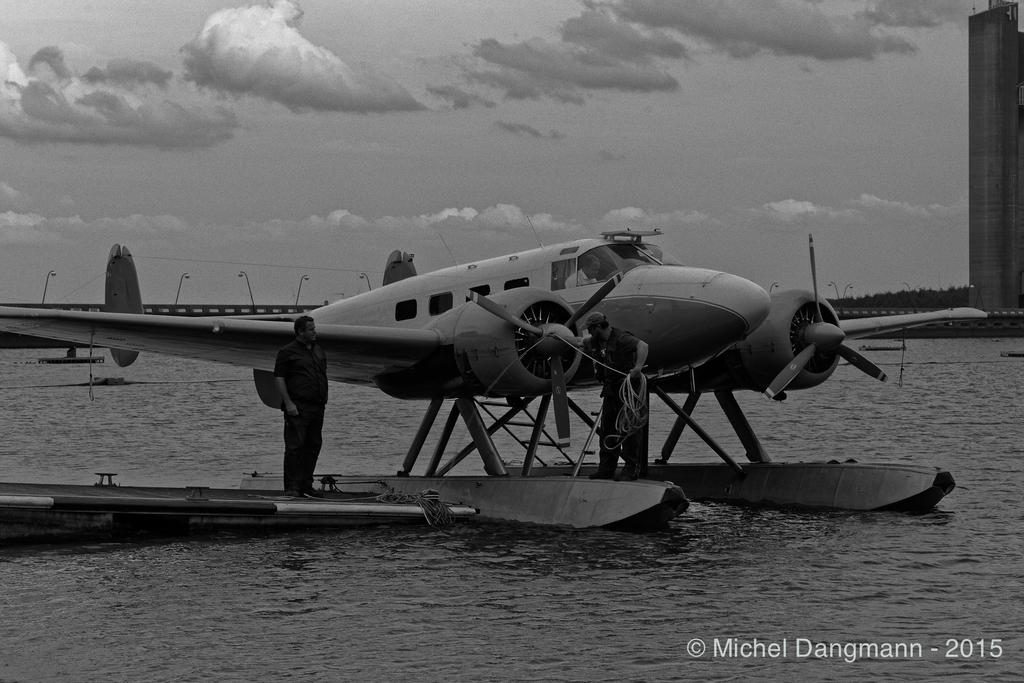<image>
Describe the image concisely. A water ski plane is sitting on the water with the date 2015. 